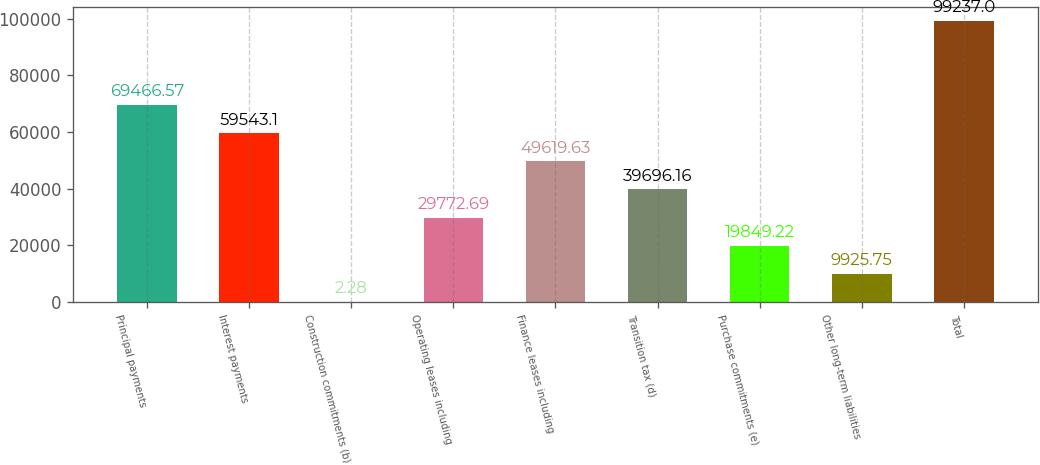<chart> <loc_0><loc_0><loc_500><loc_500><bar_chart><fcel>Principal payments<fcel>Interest payments<fcel>Construction commitments (b)<fcel>Operating leases including<fcel>Finance leases including<fcel>Transition tax (d)<fcel>Purchase commitments (e)<fcel>Other long-term liabilities<fcel>Total<nl><fcel>69466.6<fcel>59543.1<fcel>2.28<fcel>29772.7<fcel>49619.6<fcel>39696.2<fcel>19849.2<fcel>9925.75<fcel>99237<nl></chart> 